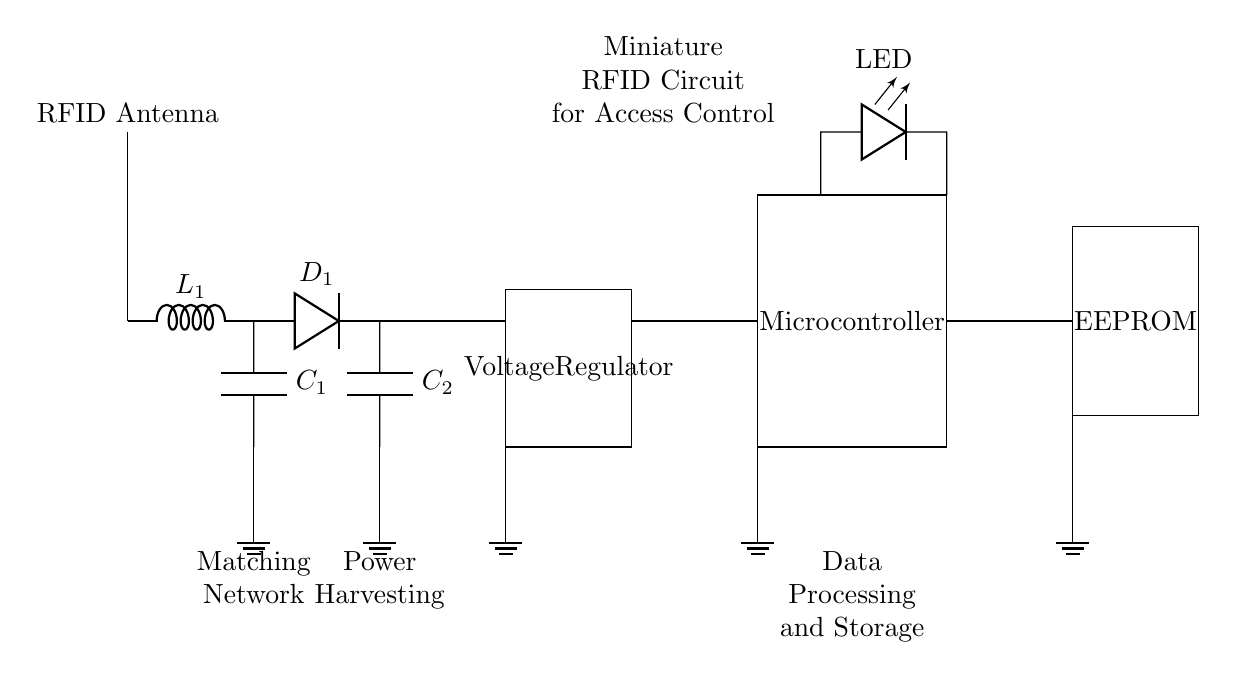What component is responsible for rectifying the AC signal? The component that rectifies the AC signal in the circuit is the diode, labeled as D1. It converts the alternating current produced by the RFID antenna to direct current.
Answer: Diode What is the purpose of the voltage regulator in this circuit? The voltage regulator ensures that the output voltage remains stable and within a specific range, even when there are variations in the input voltage or load conditions. This is crucial for powering sensitive components like the microcontroller.
Answer: Stabilize voltage Which component stores data in this circuit? The component that stores data in the circuit is the EEPROM, which retains information even when the power is off. This is important for an access control system to keep track of user credentials or access logs.
Answer: EEPROM How many main functional blocks are present in the circuit? The circuit consists of four main functional blocks: the matching network, power harvesting, data processing and storage, and LED indicator. Each block has a specific role in the operation of the RFID device.
Answer: Four What does the LED indicator signify in this circuit? The LED indicator visually indicates the operational status or success of access authentication. When the microcontroller receives a valid RFID signal, it may trigger the LED to light up as feedback to the user.
Answer: Operational status Describe the relationship between the matching network and the RFID antenna. The matching network, consisting of the inductor L1 and capacitor C1, is connected directly to the RFID antenna. Its role is to optimize the power transfer from the antenna to the rectifier by matching the antenna’s impedance to that of the circuit.
Answer: Power optimization 